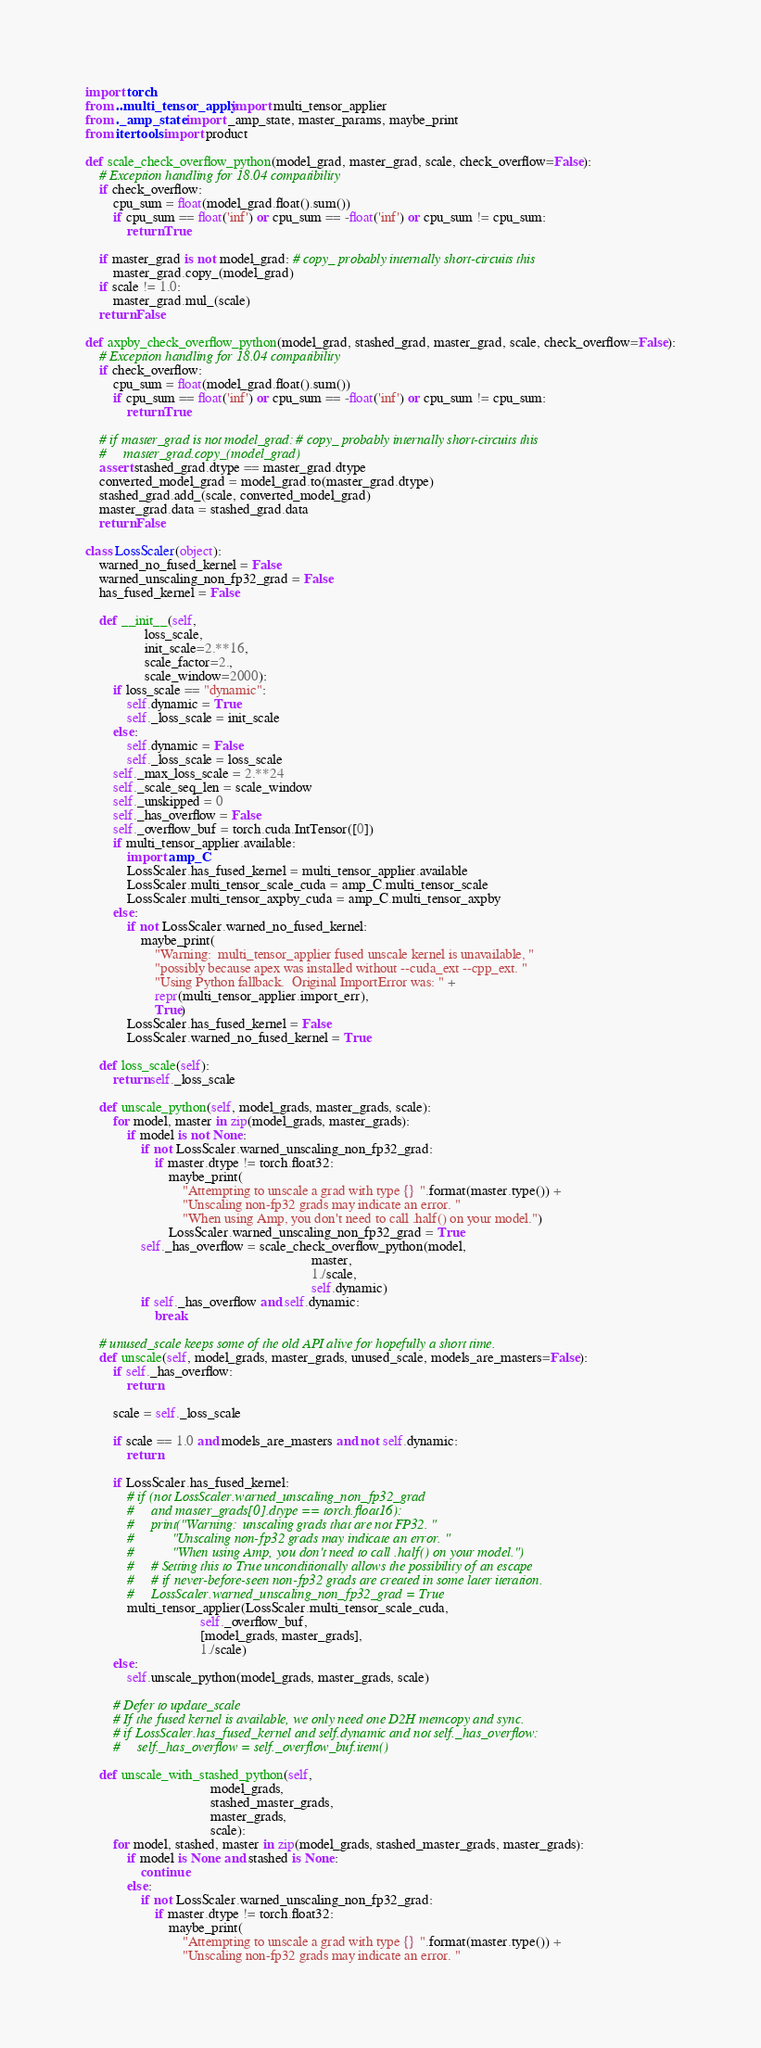<code> <loc_0><loc_0><loc_500><loc_500><_Python_>import torch
from ..multi_tensor_apply import multi_tensor_applier
from ._amp_state import _amp_state, master_params, maybe_print
from itertools import product

def scale_check_overflow_python(model_grad, master_grad, scale, check_overflow=False):
    # Exception handling for 18.04 compatibility
    if check_overflow:
        cpu_sum = float(model_grad.float().sum())
        if cpu_sum == float('inf') or cpu_sum == -float('inf') or cpu_sum != cpu_sum:
            return True

    if master_grad is not model_grad: # copy_ probably internally short-circuits this
        master_grad.copy_(model_grad)
    if scale != 1.0:
        master_grad.mul_(scale)
    return False

def axpby_check_overflow_python(model_grad, stashed_grad, master_grad, scale, check_overflow=False):
    # Exception handling for 18.04 compatibility
    if check_overflow:
        cpu_sum = float(model_grad.float().sum())
        if cpu_sum == float('inf') or cpu_sum == -float('inf') or cpu_sum != cpu_sum:
            return True

    # if master_grad is not model_grad: # copy_ probably internally short-circuits this
    #     master_grad.copy_(model_grad)
    assert stashed_grad.dtype == master_grad.dtype
    converted_model_grad = model_grad.to(master_grad.dtype)
    stashed_grad.add_(scale, converted_model_grad)
    master_grad.data = stashed_grad.data
    return False

class LossScaler(object):
    warned_no_fused_kernel = False
    warned_unscaling_non_fp32_grad = False
    has_fused_kernel = False

    def __init__(self,
                 loss_scale,
                 init_scale=2.**16,
                 scale_factor=2.,
                 scale_window=2000):
        if loss_scale == "dynamic":
            self.dynamic = True
            self._loss_scale = init_scale
        else:
            self.dynamic = False
            self._loss_scale = loss_scale
        self._max_loss_scale = 2.**24
        self._scale_seq_len = scale_window
        self._unskipped = 0
        self._has_overflow = False
        self._overflow_buf = torch.cuda.IntTensor([0])
        if multi_tensor_applier.available:
            import amp_C
            LossScaler.has_fused_kernel = multi_tensor_applier.available
            LossScaler.multi_tensor_scale_cuda = amp_C.multi_tensor_scale
            LossScaler.multi_tensor_axpby_cuda = amp_C.multi_tensor_axpby
        else:
            if not LossScaler.warned_no_fused_kernel:
                maybe_print(
                    "Warning:  multi_tensor_applier fused unscale kernel is unavailable, "
                    "possibly because apex was installed without --cuda_ext --cpp_ext. "
                    "Using Python fallback.  Original ImportError was: " +
                    repr(multi_tensor_applier.import_err),
                    True)
            LossScaler.has_fused_kernel = False
            LossScaler.warned_no_fused_kernel = True

    def loss_scale(self):
        return self._loss_scale

    def unscale_python(self, model_grads, master_grads, scale):
        for model, master in zip(model_grads, master_grads):
            if model is not None:
                if not LossScaler.warned_unscaling_non_fp32_grad:
                    if master.dtype != torch.float32:
                        maybe_print(
                            "Attempting to unscale a grad with type {} ".format(master.type()) +
                            "Unscaling non-fp32 grads may indicate an error. "
                            "When using Amp, you don't need to call .half() on your model.")
                        LossScaler.warned_unscaling_non_fp32_grad = True
                self._has_overflow = scale_check_overflow_python(model,
                                                                 master,
                                                                 1./scale,
                                                                 self.dynamic)
                if self._has_overflow and self.dynamic:
                    break

    # unused_scale keeps some of the old API alive for hopefully a short time.
    def unscale(self, model_grads, master_grads, unused_scale, models_are_masters=False):
        if self._has_overflow:
            return

        scale = self._loss_scale

        if scale == 1.0 and models_are_masters and not self.dynamic:
            return

        if LossScaler.has_fused_kernel:
            # if (not LossScaler.warned_unscaling_non_fp32_grad
            #     and master_grads[0].dtype == torch.float16):
            #     print("Warning:  unscaling grads that are not FP32. "
            #           "Unscaling non-fp32 grads may indicate an error. "
            #           "When using Amp, you don't need to call .half() on your model.")
            #     # Setting this to True unconditionally allows the possibility of an escape
            #     # if never-before-seen non-fp32 grads are created in some later iteration.
            #     LossScaler.warned_unscaling_non_fp32_grad = True
            multi_tensor_applier(LossScaler.multi_tensor_scale_cuda,
                                 self._overflow_buf,
                                 [model_grads, master_grads],
                                 1./scale)
        else:
            self.unscale_python(model_grads, master_grads, scale)

        # Defer to update_scale
        # If the fused kernel is available, we only need one D2H memcopy and sync.
        # if LossScaler.has_fused_kernel and self.dynamic and not self._has_overflow:
        #     self._has_overflow = self._overflow_buf.item()

    def unscale_with_stashed_python(self,
                                    model_grads,
                                    stashed_master_grads,
                                    master_grads,
                                    scale):
        for model, stashed, master in zip(model_grads, stashed_master_grads, master_grads):
            if model is None and stashed is None:
                continue
            else:
                if not LossScaler.warned_unscaling_non_fp32_grad:
                    if master.dtype != torch.float32:
                        maybe_print(
                            "Attempting to unscale a grad with type {} ".format(master.type()) +
                            "Unscaling non-fp32 grads may indicate an error. "</code> 